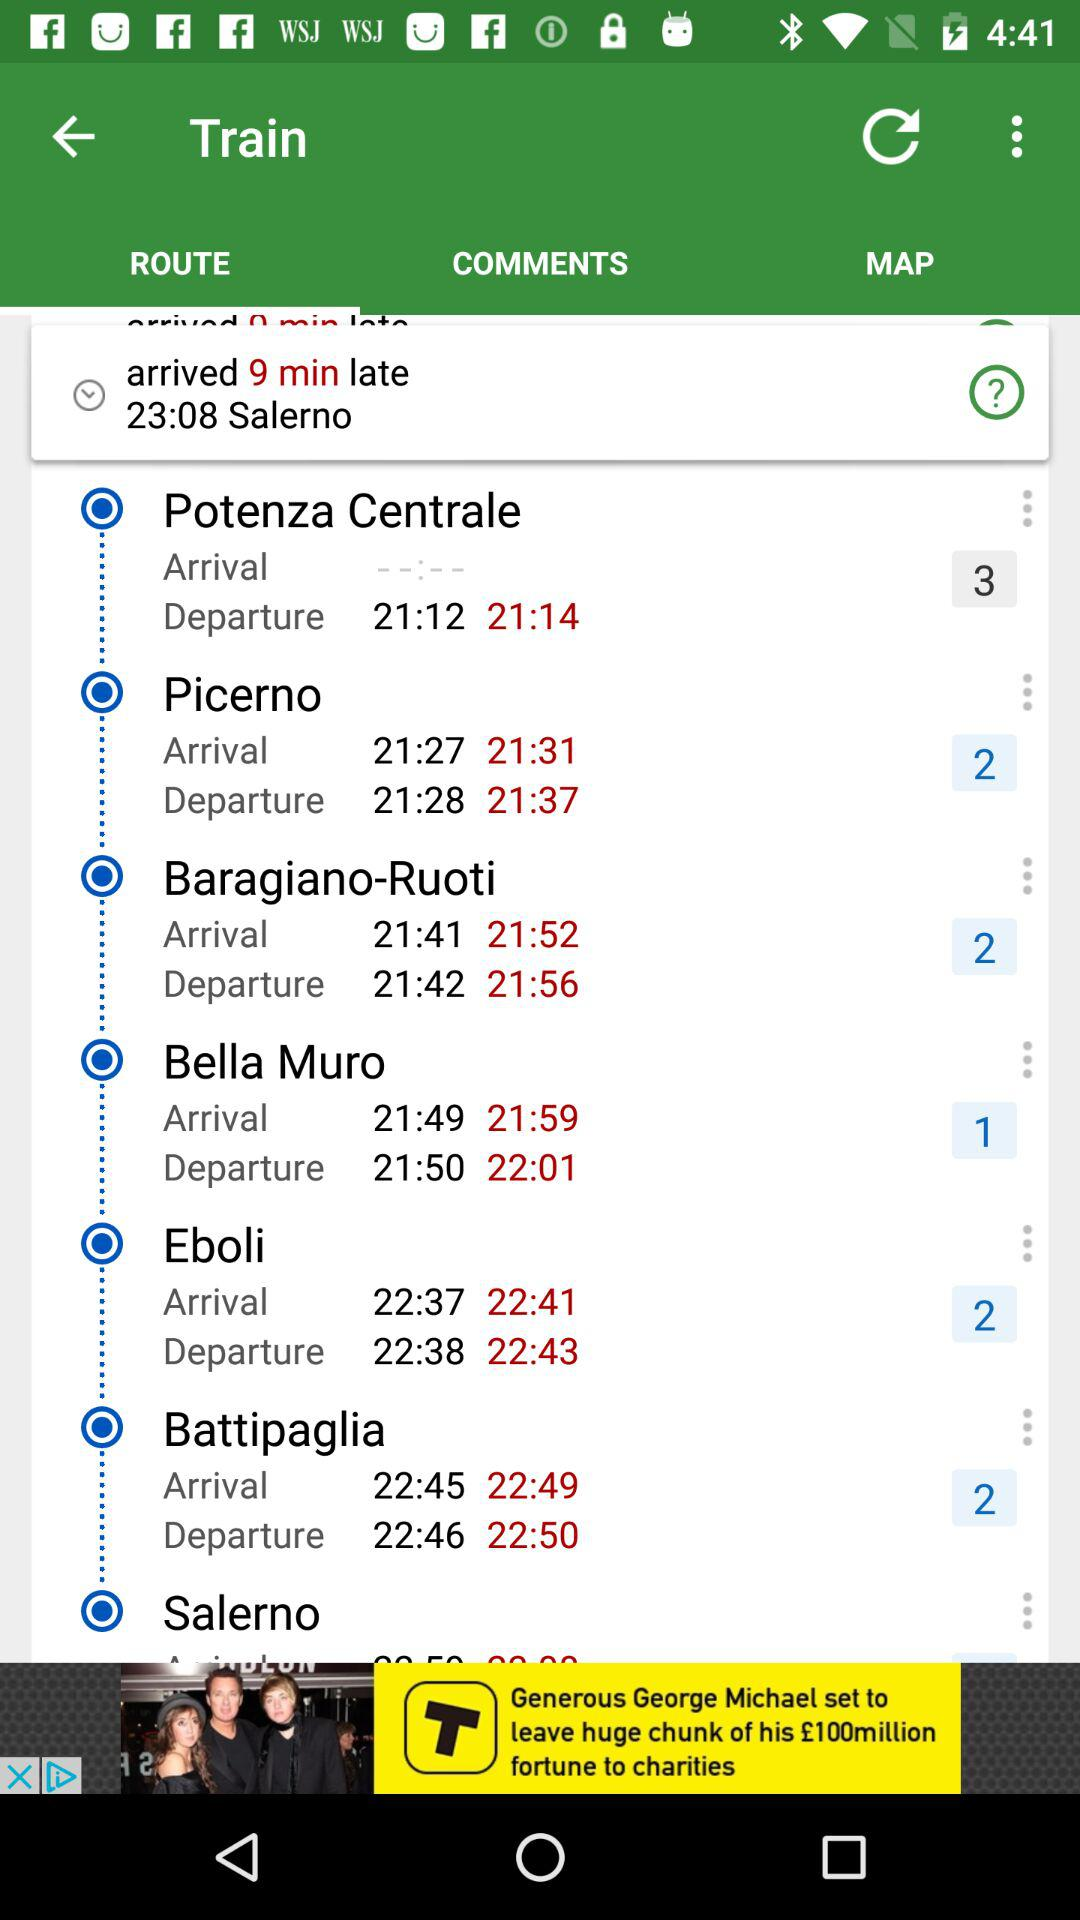What was the actual arrival time of the train at "Bella Muro"? The actual arrival time of the train at "Bella Muro" was 21:59. 